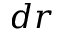<formula> <loc_0><loc_0><loc_500><loc_500>d r</formula> 